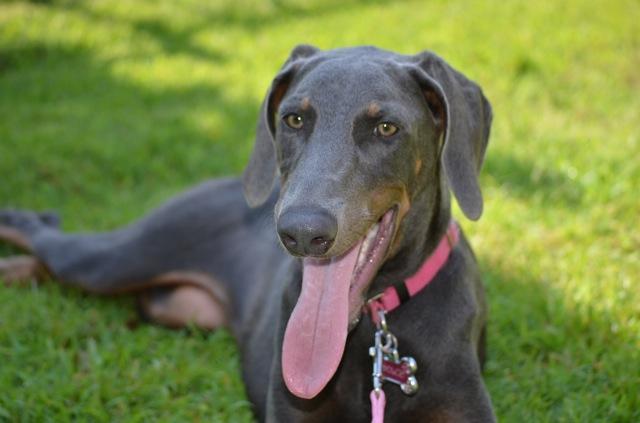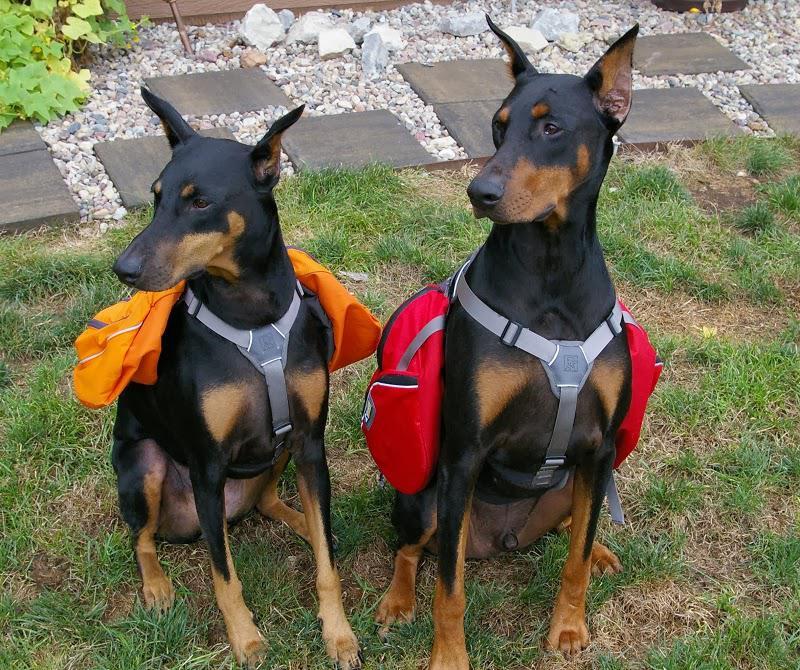The first image is the image on the left, the second image is the image on the right. Given the left and right images, does the statement "There is only one dog in each image and it has a collar on." hold true? Answer yes or no. No. The first image is the image on the left, the second image is the image on the right. Examine the images to the left and right. Is the description "There is only one dog in each picture and both have similar positions." accurate? Answer yes or no. No. 